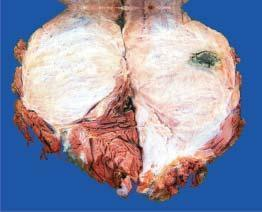s cut surface grey-white fleshy with areas of haemorrhage and necrosis?
Answer the question using a single word or phrase. Yes 